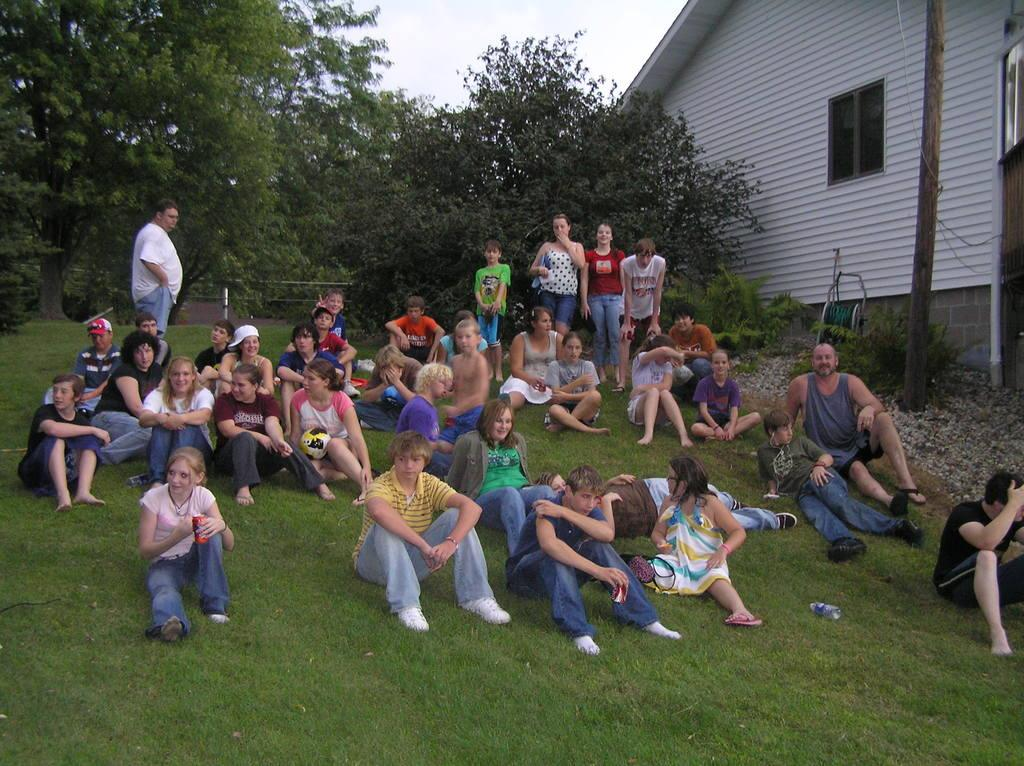What is happening on the ground in the image? There are people on the ground in the image. What are some of the people doing in the image? Some people are holding objects in the image. What type of natural environment is visible in the image? There are trees and grass in the image. What type of structure is present in the image? There is a house in the image. What architectural feature can be seen in the house? There are windows in the image. What type of underwear is being distributed in the image? There is no mention of underwear or distribution in the image; it features people on the ground, trees, grass, a house, and windows. 